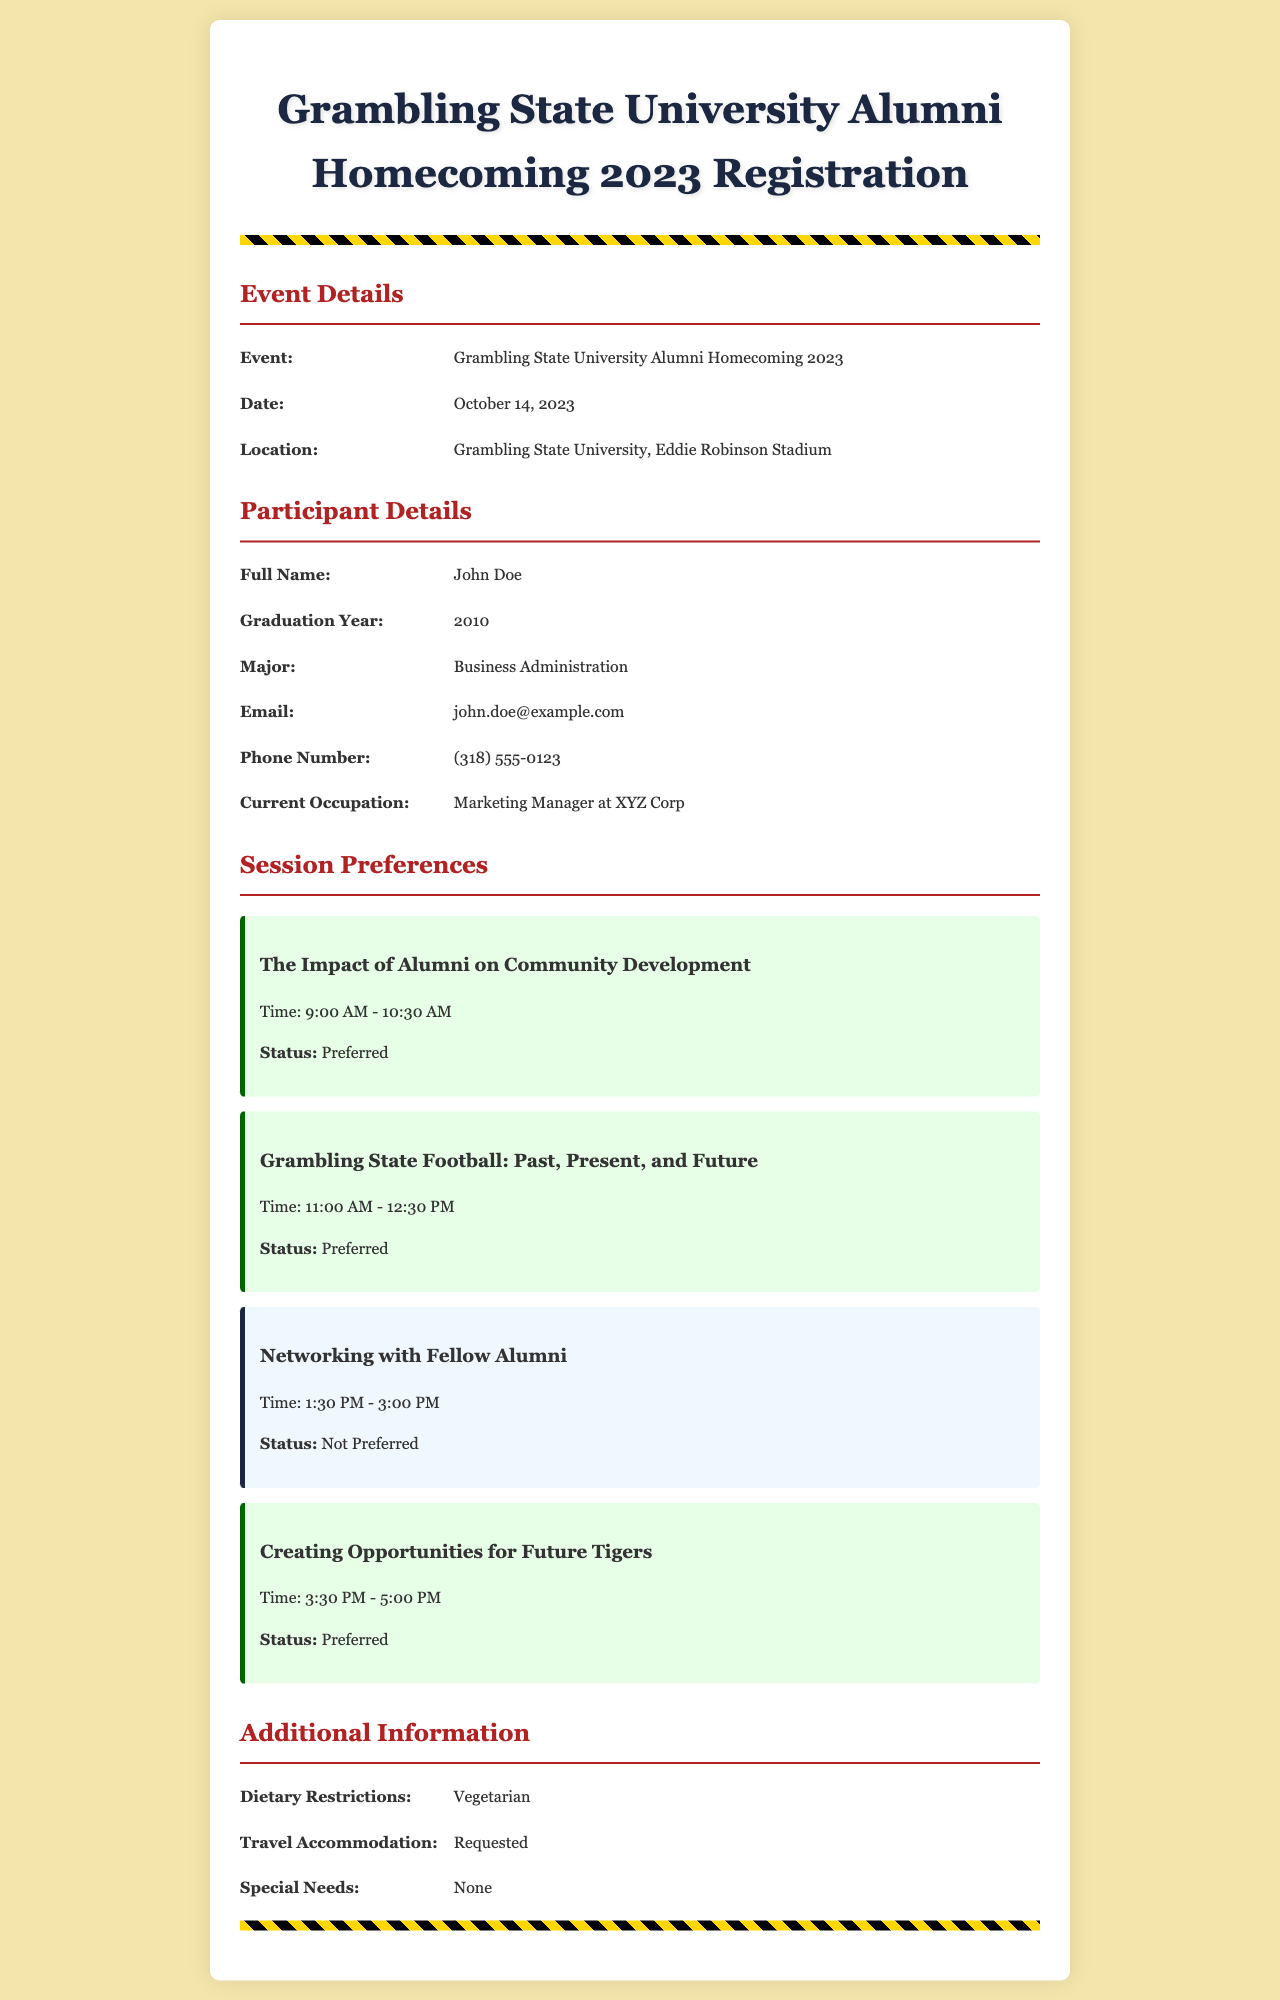What is the date of the event? The document states that the event is on October 14, 2023.
Answer: October 14, 2023 Who is the participant? The participant's full name is provided as John Doe in the document.
Answer: John Doe What is John Doe's graduation year? The document indicates that John Doe graduated in 2010.
Answer: 2010 What are the dietary restrictions listed? The document mentions that the dietary restriction for the participant is vegetarian.
Answer: Vegetarian Which session is preferred at 9:00 AM? The session titled "The Impact of Alumni on Community Development" is scheduled for 9:00 AM and marked as preferred.
Answer: The Impact of Alumni on Community Development How many sessions are marked as preferred? The document indicates that four sessions are marked as preferred.
Answer: Four What is John Doe's current occupation? The participant's current occupation is mentioned as Marketing Manager at XYZ Corp in the document.
Answer: Marketing Manager at XYZ Corp What is the location of the event? The document states that the event will take place at Eddie Robinson Stadium, Grambling State University.
Answer: Eddie Robinson Stadium What session goes from 1:30 PM to 3:00 PM? The session titled "Networking with Fellow Alumni" is scheduled for that time and marked as not preferred.
Answer: Networking with Fellow Alumni 